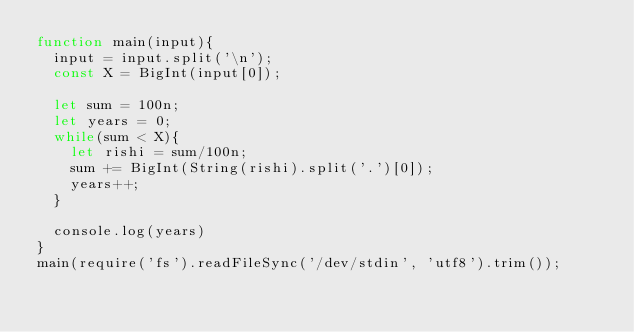Convert code to text. <code><loc_0><loc_0><loc_500><loc_500><_JavaScript_>function main(input){
  input = input.split('\n');
  const X = BigInt(input[0]);

  let sum = 100n;
  let years = 0;
  while(sum < X){
    let rishi = sum/100n;
    sum += BigInt(String(rishi).split('.')[0]);
    years++;
  }

  console.log(years)
}
main(require('fs').readFileSync('/dev/stdin', 'utf8').trim());
</code> 